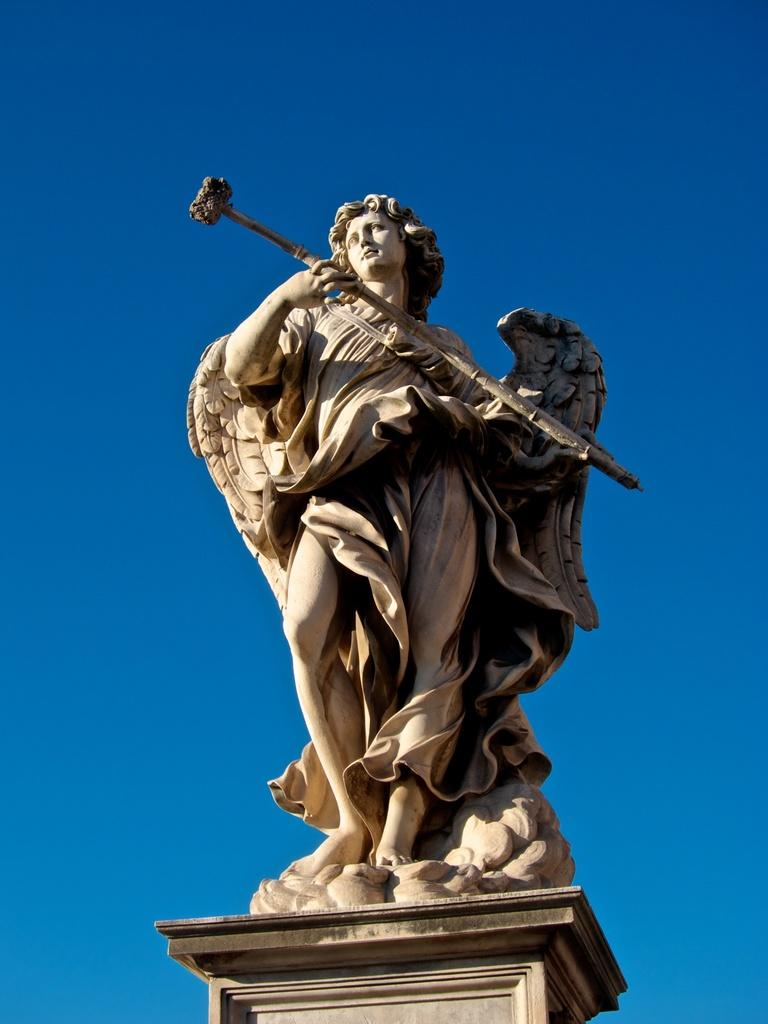What is the main subject in the center of the image? There is a statue in the center of the image. What type of event or competition is taking place around the statue in the image? There is no event or competition depicted in the image; it only features a statue. What kind of trouble is the statue causing in the image? The statue is not causing any trouble in the image; it is a stationary object. 